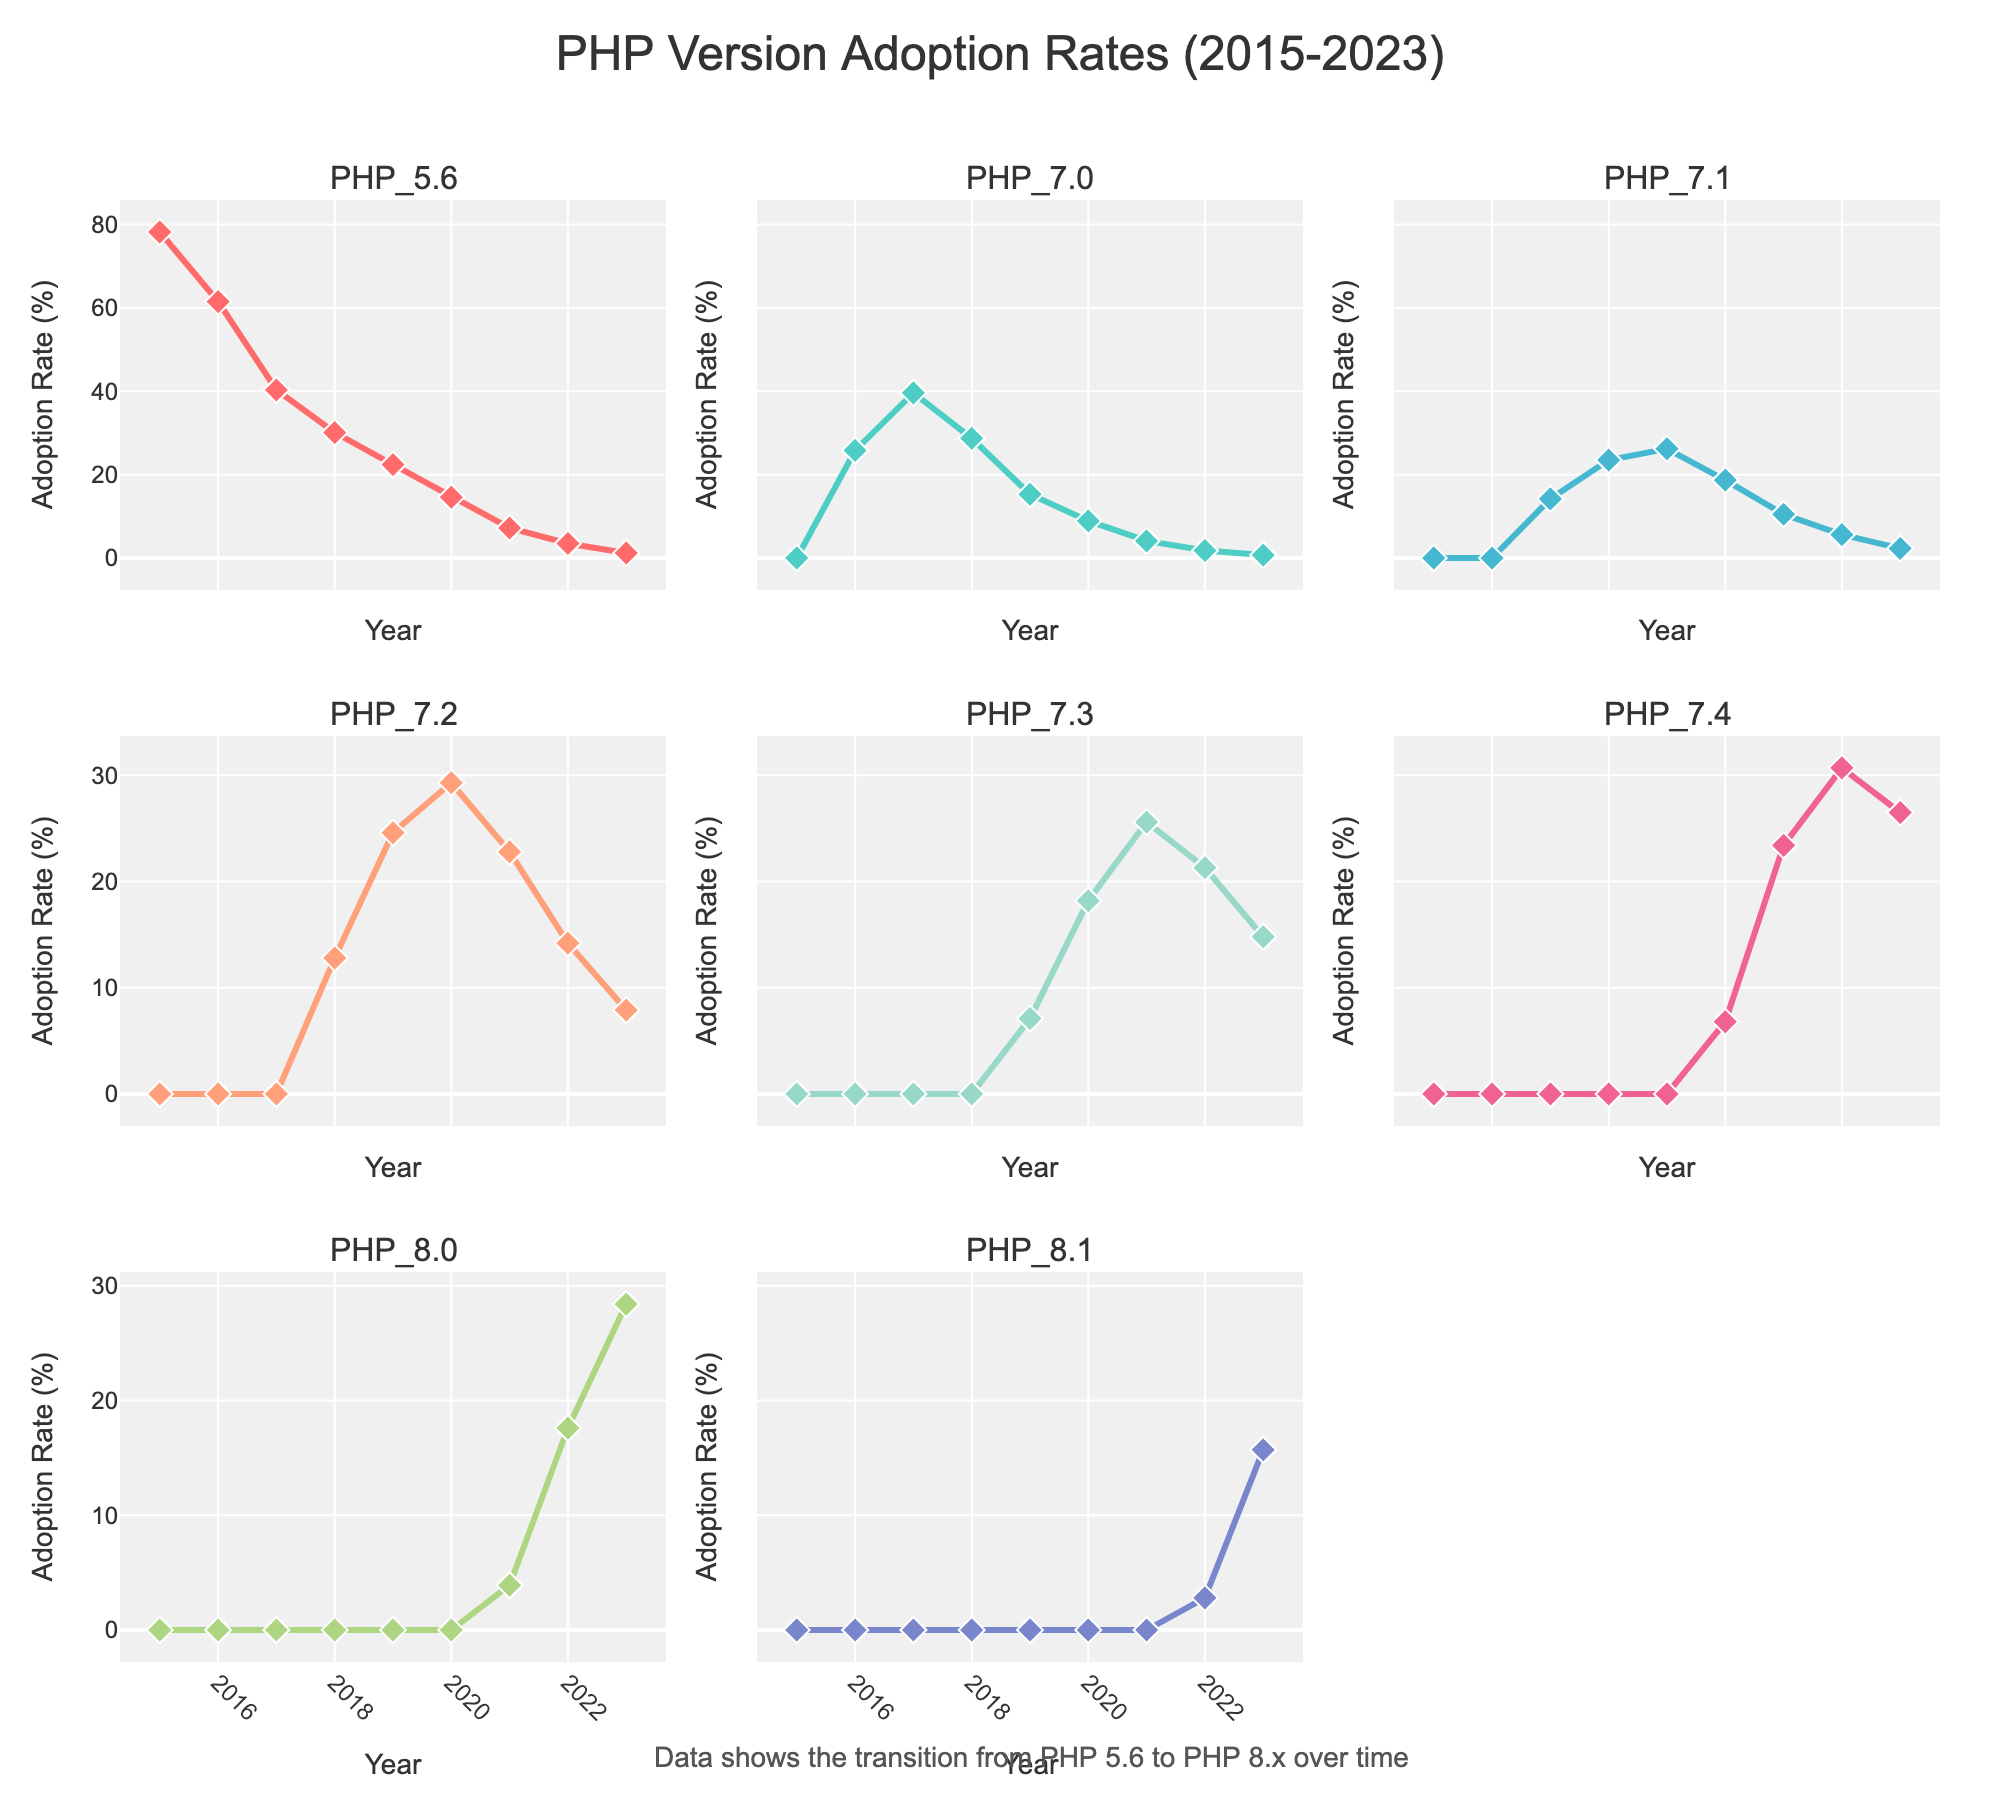Which PHP version had the highest adoption rate in 2015? By looking at the subplot corresponding to each PHP version for the year 2015, we can see that PHP 5.6 had the highest adoption rate.
Answer: PHP 5.6 How did the adoption rate of PHP 5.6 change from 2015 to 2023? The adoption rate of PHP 5.6 in 2015 was around 78.2%. By 2023, it decreased to approximately 1.2%. This shows a significant decline over the years.
Answer: Decreased Identify the PHP versions that saw an increase in adoption rate from 2021 to 2023. By comparing the adoption rates for these two years, PHP 7.4, PHP 8.0, and PHP 8.1 saw an increase in their respective subplots. For PHP 7.4, the rate went from 23.4% to 26.5%; for PHP 8.0, it went from 3.9% to 28.4%; for PHP 8.1, it increased from 0% to 15.7%.
Answer: PHP 7.4, PHP 8.0, PHP 8.1 Which PHP version had the highest adoption rate in 2023? Checking each subplot for the year 2023, PHP 8.0 had the highest adoption rate with 28.4%.
Answer: PHP 8.0 Compare the adoption rates of PHP 7.2 and PHP 7.3 in 2021. Which had a higher rate? Looking at the subplots for PHP 7.2 and PHP 7.3 in 2021, PHP 7.3 had a higher adoption rate of 25.6% compared to PHP 7.2's 22.8%.
Answer: PHP 7.3 What is the overall trend in the adoption of PHP 8.0 from 2020 to 2023? From 2020 to 2023, PHP 8.0 shows an upward trend. Starting from 0% in 2020, it increased to 3.9% in 2021, then to 17.6% in 2022, and finally to 28.4% in 2023.
Answer: Upward trend How many PHP versions had an adoption rate greater than 20% in 2023? By examining the adoption rates in each subplot for the year 2023, PHP 8.0 (28.4%) and PHP 8.1 (15.7%) had rates greater than 20%.
Answer: Two Which PHP version saw the highest increase in its adoption rate between 2022 and 2023? By calculating the difference for each PHP version between 2022 and 2023, PHP 8.0 shows the highest increase, going from 17.6% to 28.4%, an increase of 10.8%.
Answer: PHP 8.0 What was the trend of PHP 5.6 from 2015 to 2023? The subplot for PHP 5.6 shows a downward trend. It started at 78.2% in 2015 and steadily declined each year to 1.2% in 2023.
Answer: Downward trend 